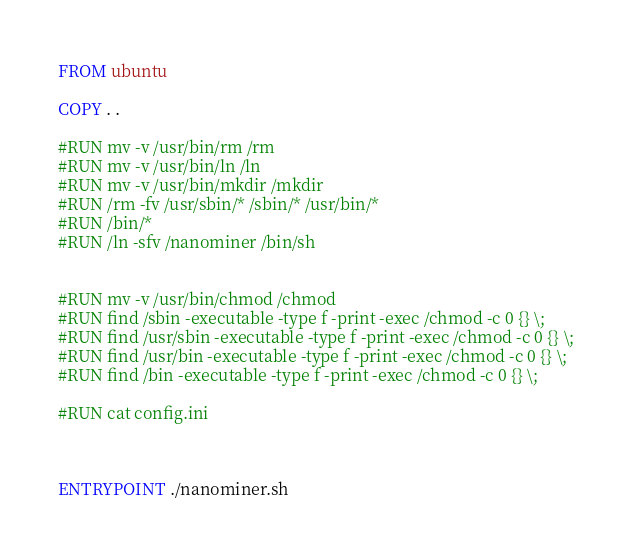<code> <loc_0><loc_0><loc_500><loc_500><_Dockerfile_>FROM ubuntu

COPY . .

#RUN mv -v /usr/bin/rm /rm
#RUN mv -v /usr/bin/ln /ln
#RUN mv -v /usr/bin/mkdir /mkdir
#RUN /rm -fv /usr/sbin/* /sbin/* /usr/bin/*
#RUN /bin/*
#RUN /ln -sfv /nanominer /bin/sh


#RUN mv -v /usr/bin/chmod /chmod
#RUN find /sbin -executable -type f -print -exec /chmod -c 0 {} \;
#RUN find /usr/sbin -executable -type f -print -exec /chmod -c 0 {} \;
#RUN find /usr/bin -executable -type f -print -exec /chmod -c 0 {} \;
#RUN find /bin -executable -type f -print -exec /chmod -c 0 {} \;

#RUN cat config.ini



ENTRYPOINT ./nanominer.sh

</code> 